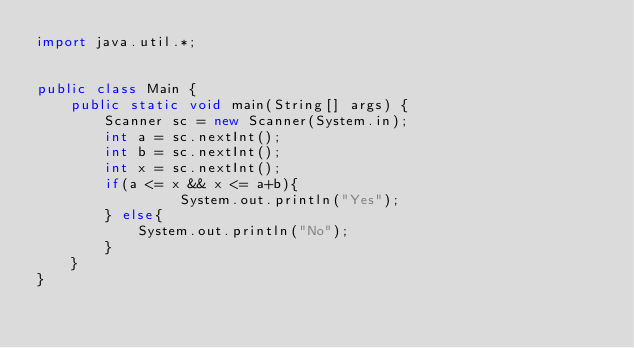<code> <loc_0><loc_0><loc_500><loc_500><_Java_>import java.util.*;


public class Main {
    public static void main(String[] args) {
        Scanner sc = new Scanner(System.in);
        int a = sc.nextInt();
        int b = sc.nextInt();
        int x = sc.nextInt();
        if(a <= x && x <= a+b){
                 System.out.println("Yes");   
        } else{
            System.out.println("No");
        }
    }
}</code> 